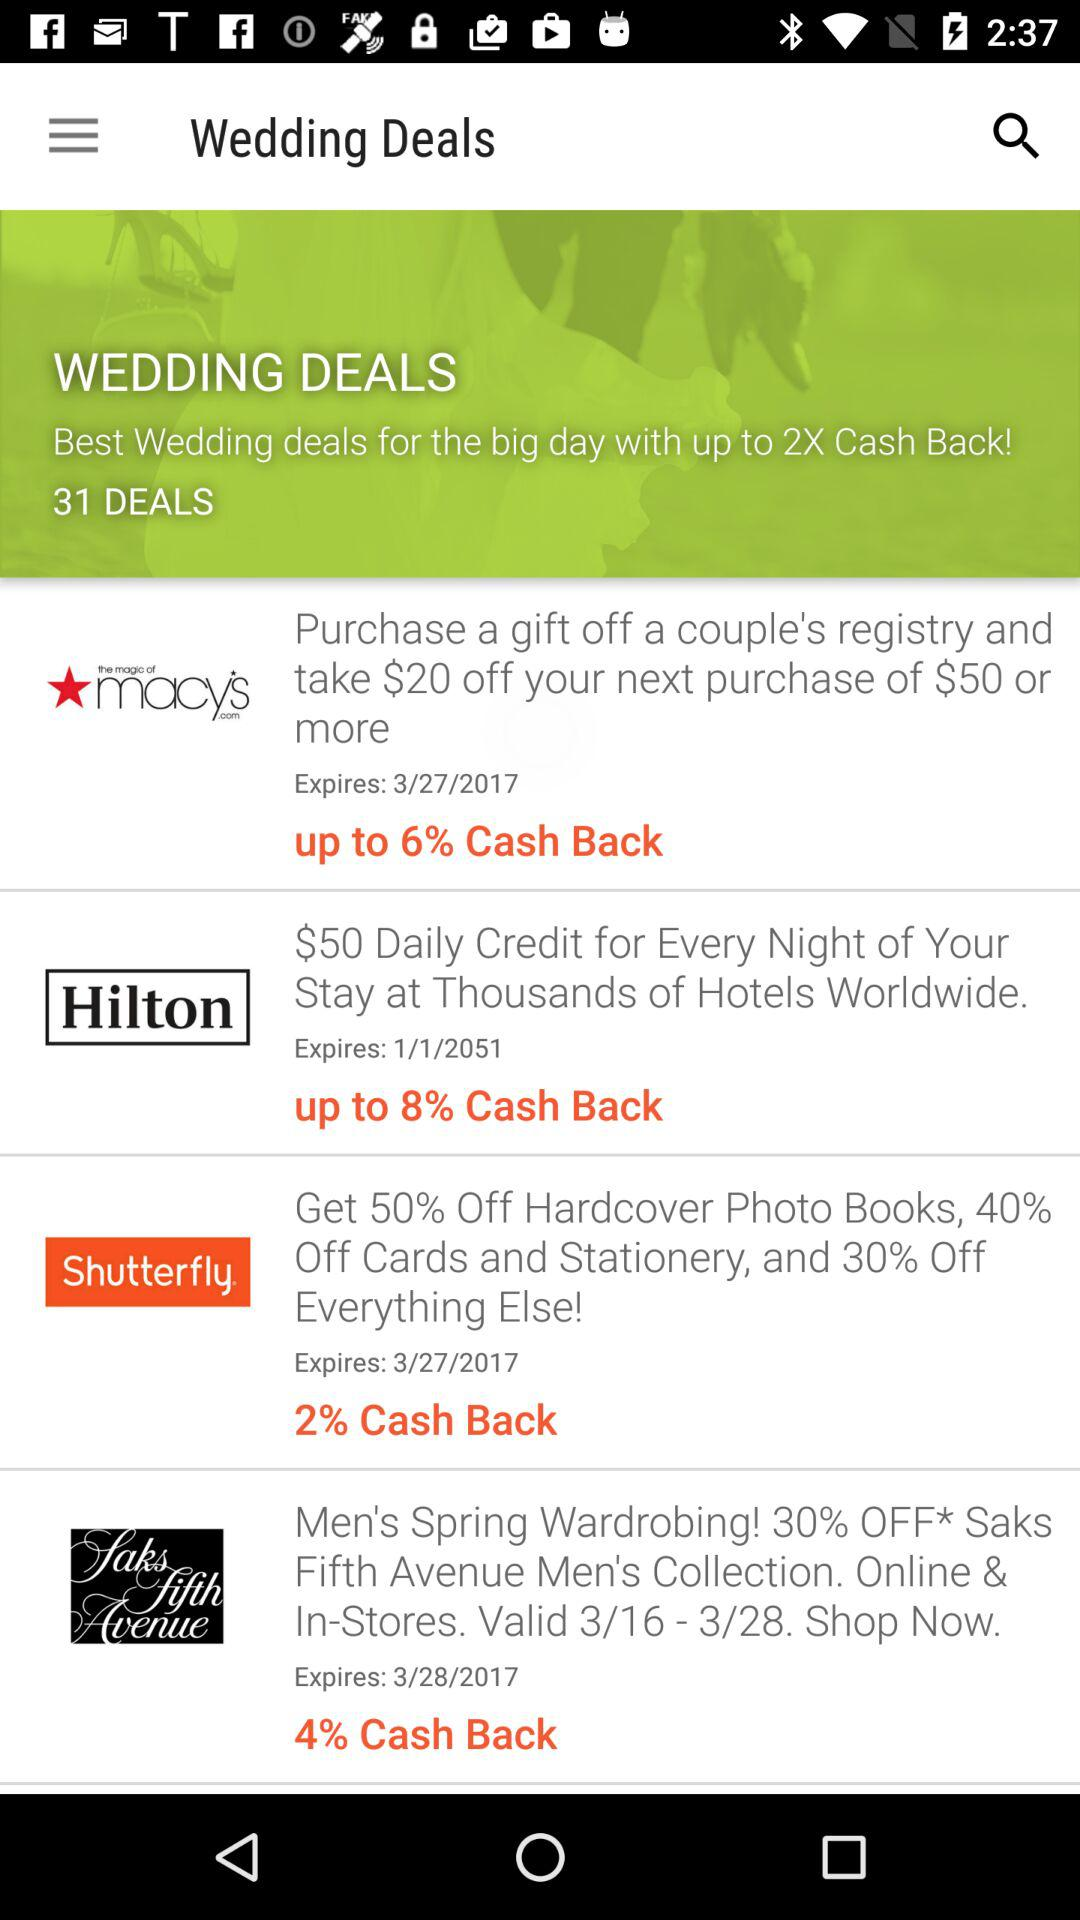When will the coupon for Shutterfly expire? The coupon will expire on March 27, 2017. 